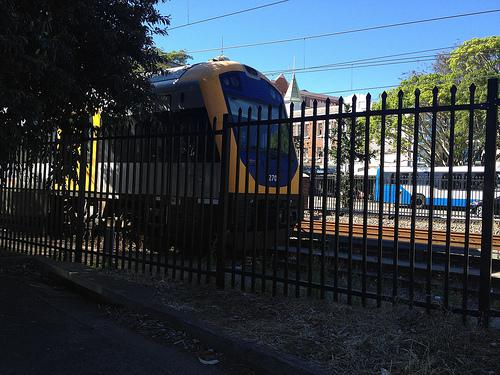Question: what color is the gate?
Choices:
A. Purple.
B. Black.
C. Brown.
D. Silver.
Answer with the letter. Answer: B Question: why is the gate there?
Choices:
A. To keep people safe.
B. To keep the horse in.
C. To keep people out.
D. To keep the prisoners in.
Answer with the letter. Answer: A Question: what color is the front of the train?
Choices:
A. Purple.
B. Brown.
C. Blue, yellow, and black.
D. Silver.
Answer with the letter. Answer: C 